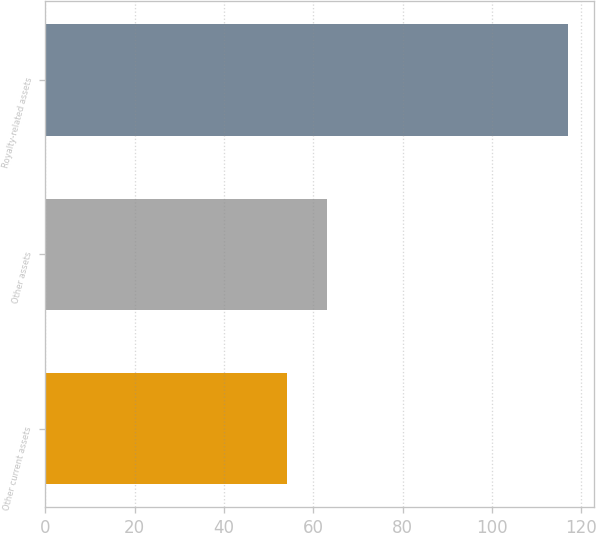<chart> <loc_0><loc_0><loc_500><loc_500><bar_chart><fcel>Other current assets<fcel>Other assets<fcel>Royalty-related assets<nl><fcel>54<fcel>63<fcel>117<nl></chart> 